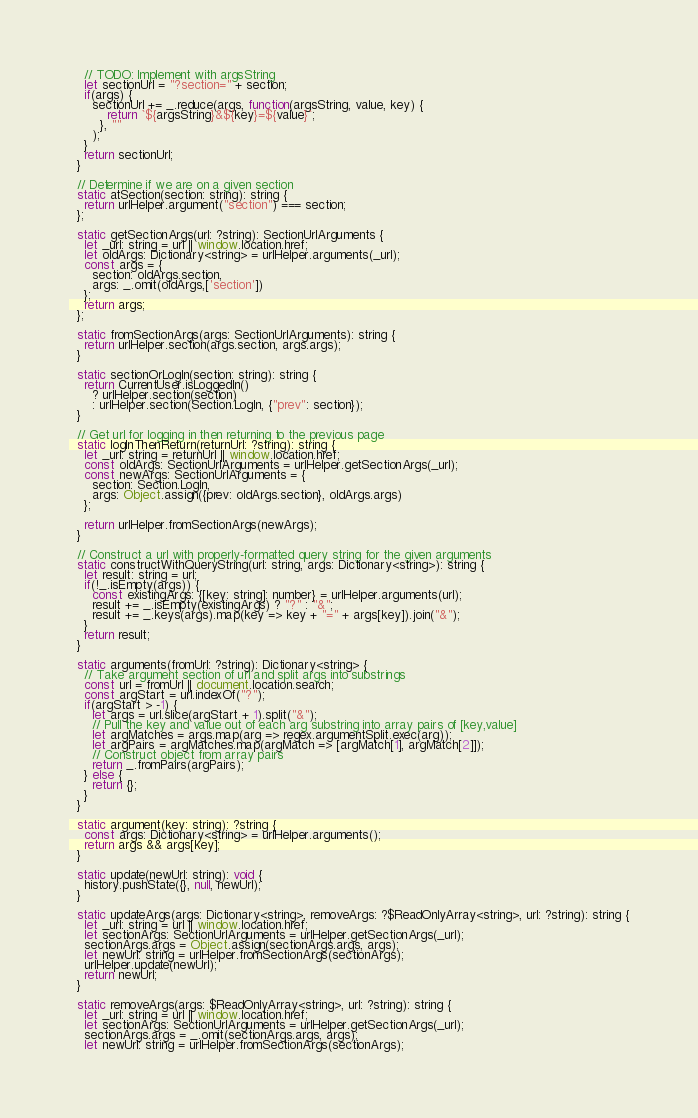Convert code to text. <code><loc_0><loc_0><loc_500><loc_500><_JavaScript_>    // TODO: Implement with argsString
    let sectionUrl = "?section=" + section;
    if(args) {
      sectionUrl += _.reduce(args, function(argsString, value, key) {
          return `${argsString}&${key}=${value}`;
        }, ""
      );
    }
    return sectionUrl;
  }
  
  // Determine if we are on a given section
  static atSection(section: string): string {
    return urlHelper.argument("section") === section;
  };
  
  static getSectionArgs(url: ?string): SectionUrlArguments {
    let _url: string = url || window.location.href;
    let oldArgs: Dictionary<string> = urlHelper.arguments(_url);
    const args = {
      section: oldArgs.section,
      args: _.omit(oldArgs,['section'])
    };
    return args;
  };
  
  static fromSectionArgs(args: SectionUrlArguments): string {
    return urlHelper.section(args.section, args.args);
  }
  
  static sectionOrLogIn(section: string): string {
    return CurrentUser.isLoggedIn()
      ? urlHelper.section(section)
      : urlHelper.section(Section.LogIn, {"prev": section});
  }
  
  // Get url for logging in then returning to the previous page
  static logInThenReturn(returnUrl: ?string): string {
    let _url: string = returnUrl || window.location.href;
    const oldArgs: SectionUrlArguments = urlHelper.getSectionArgs(_url);
    const newArgs: SectionUrlArguments = {
      section: Section.LogIn,
      args: Object.assign({prev: oldArgs.section}, oldArgs.args)
    };
    
    return urlHelper.fromSectionArgs(newArgs);
  }
  
  // Construct a url with properly-formatted query string for the given arguments
  static constructWithQueryString(url: string, args: Dictionary<string>): string {
    let result: string = url;
    if(!_.isEmpty(args)) {
      const existingArgs: {[key: string]: number} = urlHelper.arguments(url);
      result += _.isEmpty(existingArgs) ? "?" : "&";
      result += _.keys(args).map(key => key + "=" + args[key]).join("&");
    }
    return result;
  }
  
  static arguments(fromUrl: ?string): Dictionary<string> {
    // Take argument section of url and split args into substrings
    const url = fromUrl || document.location.search;
    const argStart = url.indexOf("?");
    if(argStart > -1) {
      let args = url.slice(argStart + 1).split("&");
      // Pull the key and value out of each arg substring into array pairs of [key,value]
      let argMatches = args.map(arg => regex.argumentSplit.exec(arg));
      let argPairs = argMatches.map(argMatch => [argMatch[1], argMatch[2]]);
      // Construct object from array pairs
      return _.fromPairs(argPairs);
    } else {
      return {};
    }
  }
  
  static argument(key: string): ?string {
    const args: Dictionary<string> = urlHelper.arguments();
    return args && args[key];
  }
  
  static update(newUrl: string): void {
    history.pushState({}, null, newUrl);
  }
  
  static updateArgs(args: Dictionary<string>, removeArgs: ?$ReadOnlyArray<string>, url: ?string): string {
    let _url: string = url || window.location.href;
    let sectionArgs: SectionUrlArguments = urlHelper.getSectionArgs(_url);
    sectionArgs.args = Object.assign(sectionArgs.args, args);
    let newUrl: string = urlHelper.fromSectionArgs(sectionArgs);
    urlHelper.update(newUrl);
    return newUrl;
  }
  
  static removeArgs(args: $ReadOnlyArray<string>, url: ?string): string {
    let _url: string = url || window.location.href;
    let sectionArgs: SectionUrlArguments = urlHelper.getSectionArgs(_url);
    sectionArgs.args = _.omit(sectionArgs.args, args);
    let newUrl: string = urlHelper.fromSectionArgs(sectionArgs);</code> 